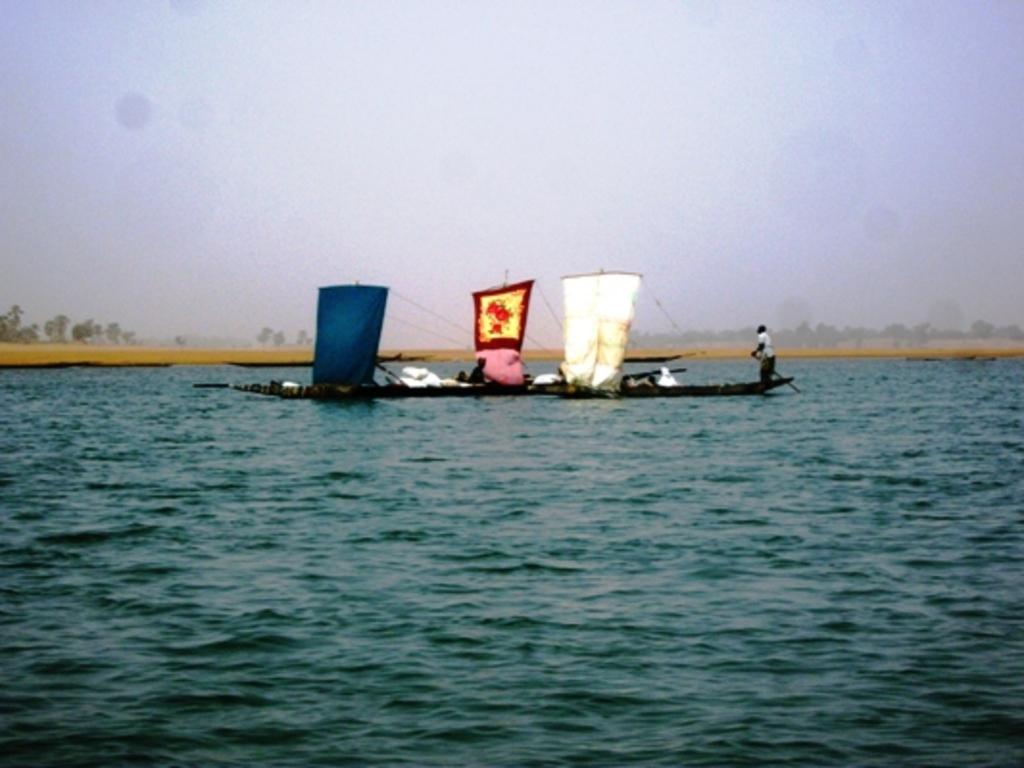Who or what is present in the image? There are people in the image. What are the people doing in the image? The people are on boats. What is the primary setting of the image? There is water visible in the image. What type of jewel can be seen on the friend's necklace in the image? There is no friend or necklace with a jewel present in the image. 